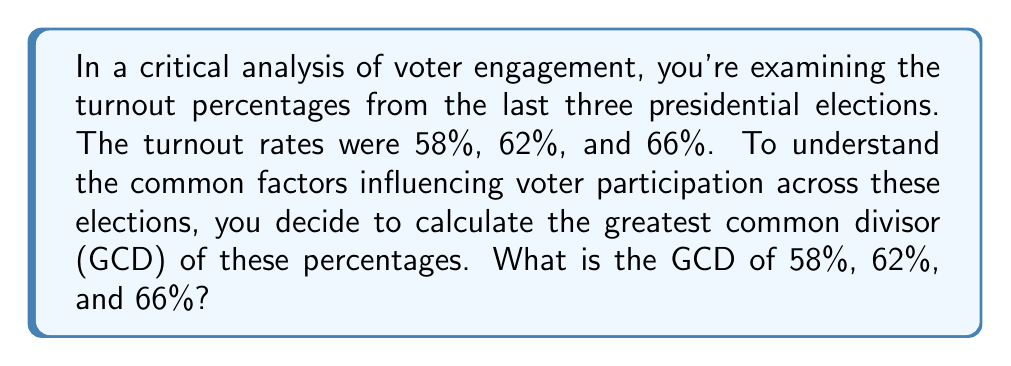Can you solve this math problem? Let's approach this step-by-step:

1) First, we need to convert the percentages to whole numbers:
   58% = 58, 62% = 62, 66% = 66

2) Now, we'll use the Euclidean algorithm to find the GCD. We start with the largest two numbers:

   $66 = 1 \times 62 + 4$
   $62 = 15 \times 4 + 2$
   $4 = 2 \times 2 + 0$

3) The last non-zero remainder is 2, so the GCD of 62 and 66 is 2.

4) Now we need to find the GCD of this result (2) and 58:

   $58 = 29 \times 2 + 0$

5) The GCD of 2 and 58 is 2.

Therefore, the GCD of 58, 62, and 66 is 2.

6) To convert back to a percentage, we divide by 100:

   $\frac{2}{100} = 0.02 = 2\%$

This 2% GCD suggests that across these elections, voter turnout consistently moved in increments of at least 2%, which could indicate a common underlying factor influencing participation rates.
Answer: 2% 